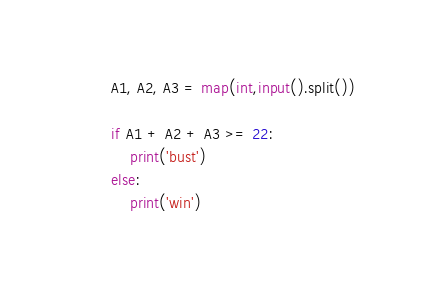<code> <loc_0><loc_0><loc_500><loc_500><_Python_>A1, A2, A3 = map(int,input().split())

if A1 + A2 + A3 >= 22:
    print('bust')
else:
    print('win')</code> 